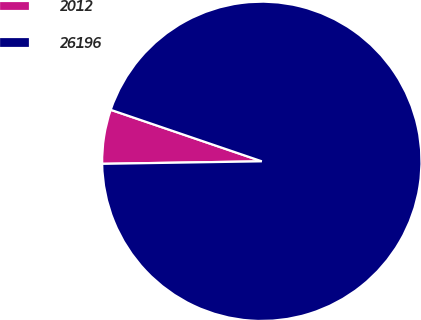Convert chart. <chart><loc_0><loc_0><loc_500><loc_500><pie_chart><fcel>2012<fcel>26196<nl><fcel>5.48%<fcel>94.52%<nl></chart> 